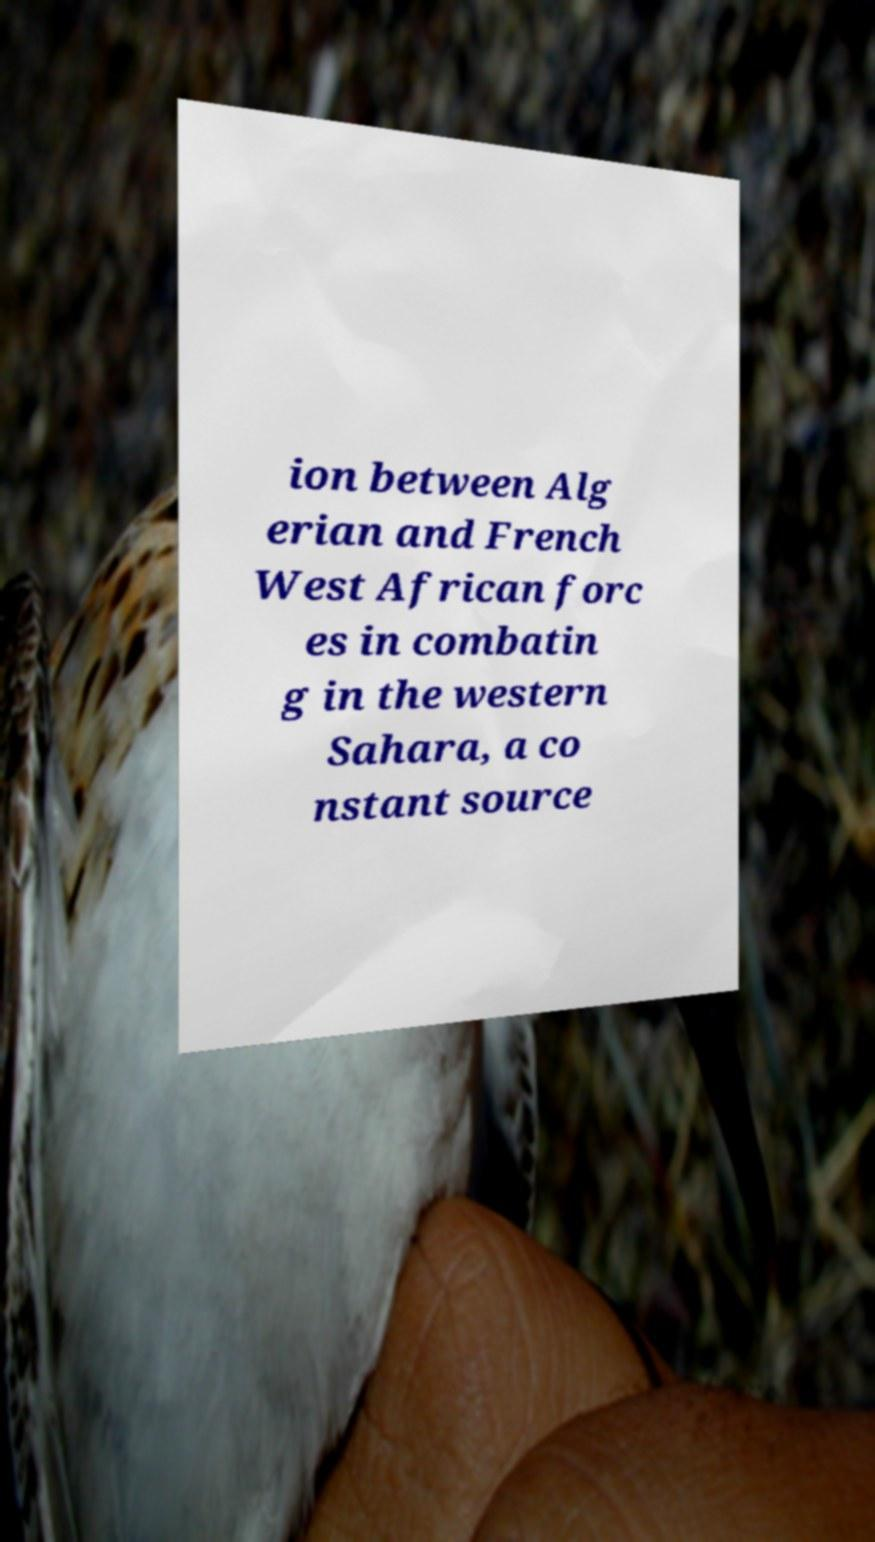Please identify and transcribe the text found in this image. ion between Alg erian and French West African forc es in combatin g in the western Sahara, a co nstant source 